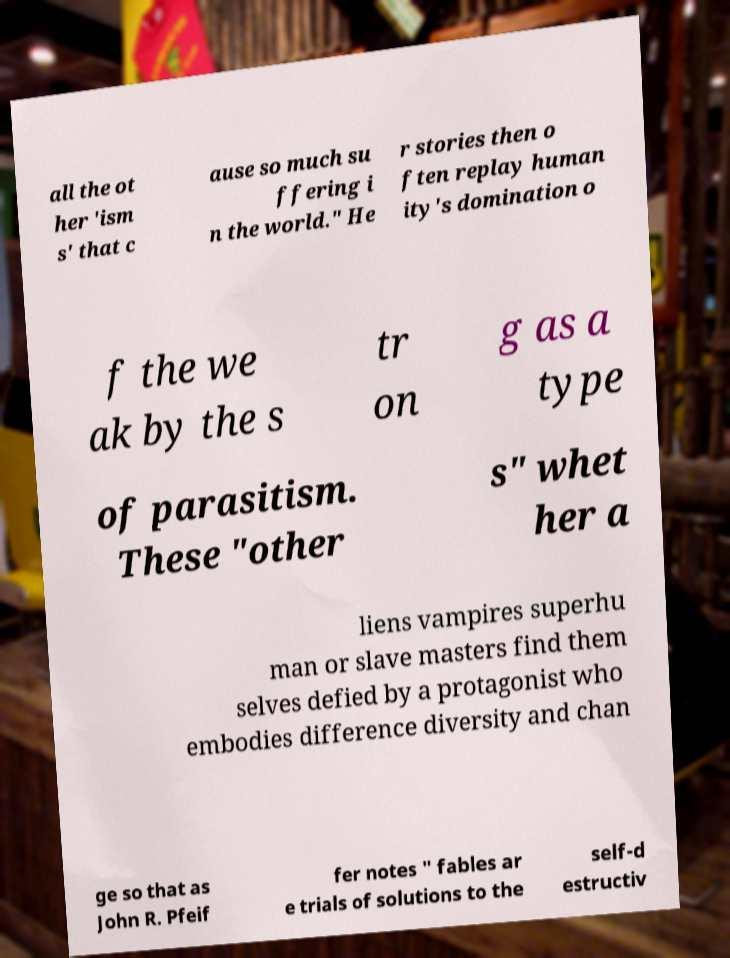There's text embedded in this image that I need extracted. Can you transcribe it verbatim? all the ot her 'ism s' that c ause so much su ffering i n the world." He r stories then o ften replay human ity's domination o f the we ak by the s tr on g as a type of parasitism. These "other s" whet her a liens vampires superhu man or slave masters find them selves defied by a protagonist who embodies difference diversity and chan ge so that as John R. Pfeif fer notes " fables ar e trials of solutions to the self-d estructiv 